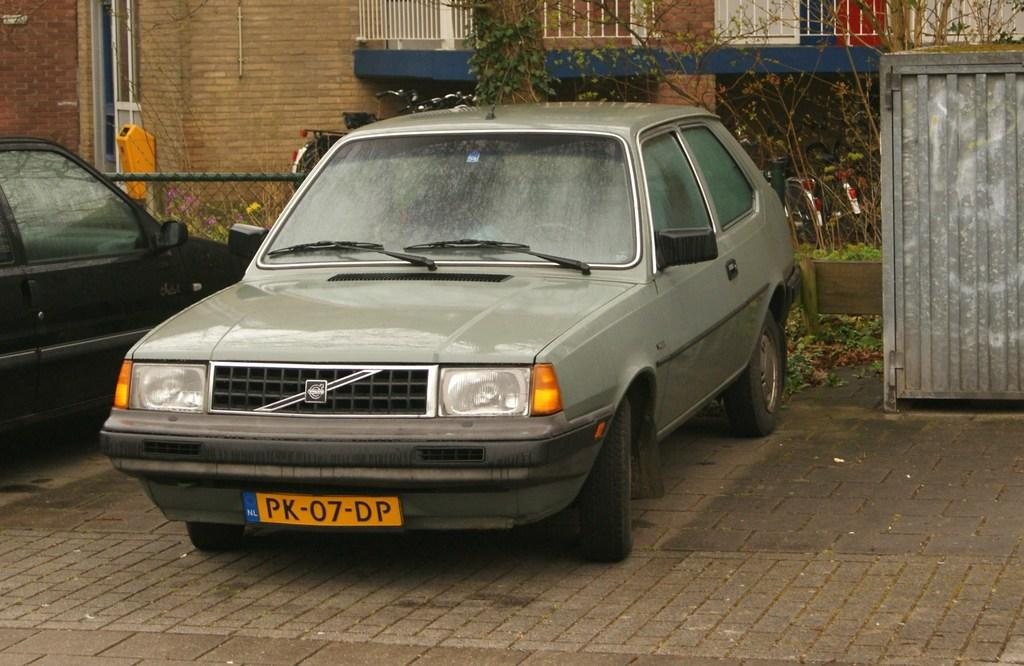What can be seen on the road in the image? There are vehicles on the road in the image. What is visible in the background of the image? There is a building and trees in the background of the image. Can you describe the door in the image? There is a door in the image, but its specific characteristics are not mentioned in the facts. What type of fencing is present in the image? There is both regular fencing and net fencing in the image. What is the color of the box in the image? The box in the image is ash-colored. How many pairs of shoes are visible in the image? There is no mention of shoes in the image, so it is not possible to answer this question. 